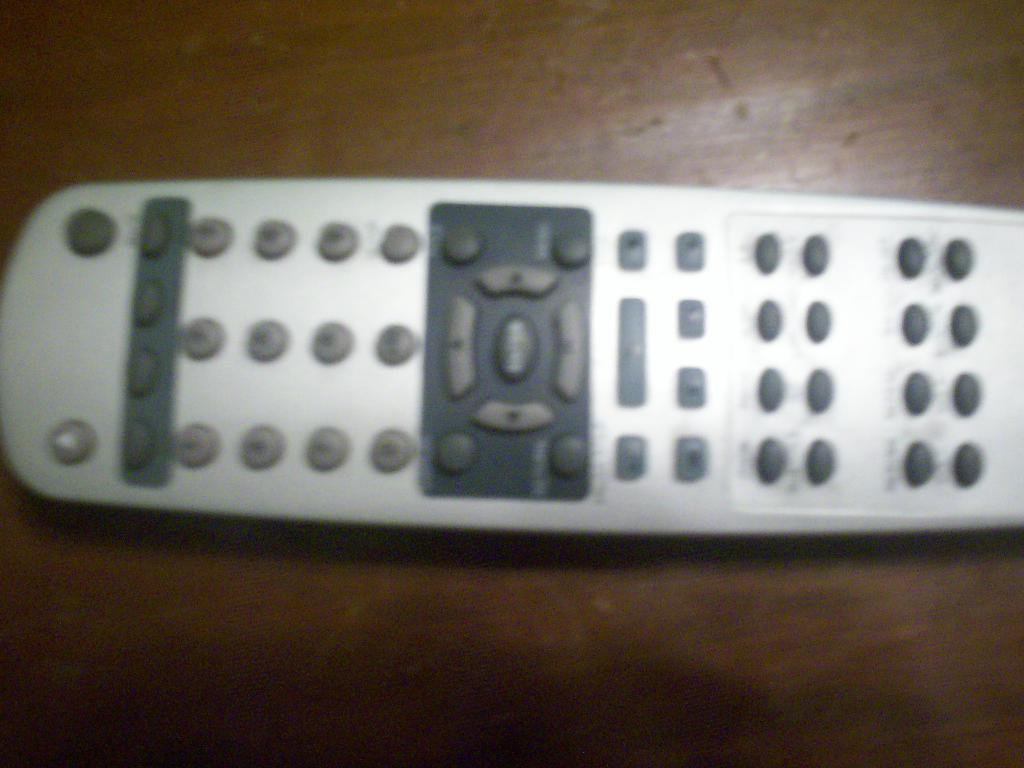What object can be seen in the picture? There is a remote in the picture. What feature is present on the remote? The remote has buttons with numbers on it. What type of flooring is visible at the bottom of the image? There is a wooden floor at the bottom of the image. How does the remote fly in the image? The remote does not fly in the image; it is stationary on a surface or in someone's hand. 